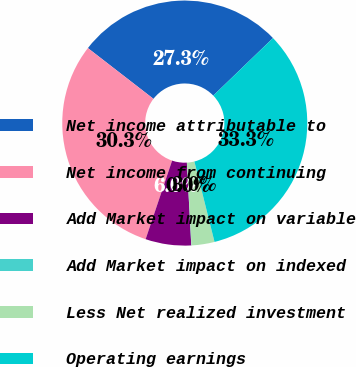Convert chart. <chart><loc_0><loc_0><loc_500><loc_500><pie_chart><fcel>Net income attributable to<fcel>Net income from continuing<fcel>Add Market impact on variable<fcel>Add Market impact on indexed<fcel>Less Net realized investment<fcel>Operating earnings<nl><fcel>27.31%<fcel>30.31%<fcel>6.02%<fcel>0.03%<fcel>3.03%<fcel>33.3%<nl></chart> 